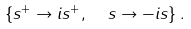Convert formula to latex. <formula><loc_0><loc_0><loc_500><loc_500>\left \{ s ^ { + } \rightarrow i s ^ { + } , \ \ s \rightarrow - i s \right \} .</formula> 